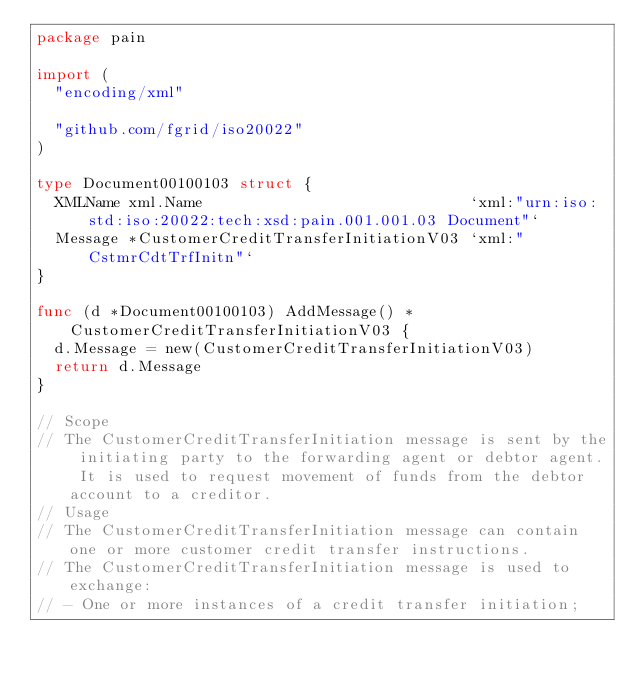Convert code to text. <code><loc_0><loc_0><loc_500><loc_500><_Go_>package pain

import (
	"encoding/xml"

	"github.com/fgrid/iso20022"
)

type Document00100103 struct {
	XMLName xml.Name                             `xml:"urn:iso:std:iso:20022:tech:xsd:pain.001.001.03 Document"`
	Message *CustomerCreditTransferInitiationV03 `xml:"CstmrCdtTrfInitn"`
}

func (d *Document00100103) AddMessage() *CustomerCreditTransferInitiationV03 {
	d.Message = new(CustomerCreditTransferInitiationV03)
	return d.Message
}

// Scope
// The CustomerCreditTransferInitiation message is sent by the initiating party to the forwarding agent or debtor agent. It is used to request movement of funds from the debtor account to a creditor.
// Usage
// The CustomerCreditTransferInitiation message can contain one or more customer credit transfer instructions.
// The CustomerCreditTransferInitiation message is used to exchange:
// - One or more instances of a credit transfer initiation;</code> 